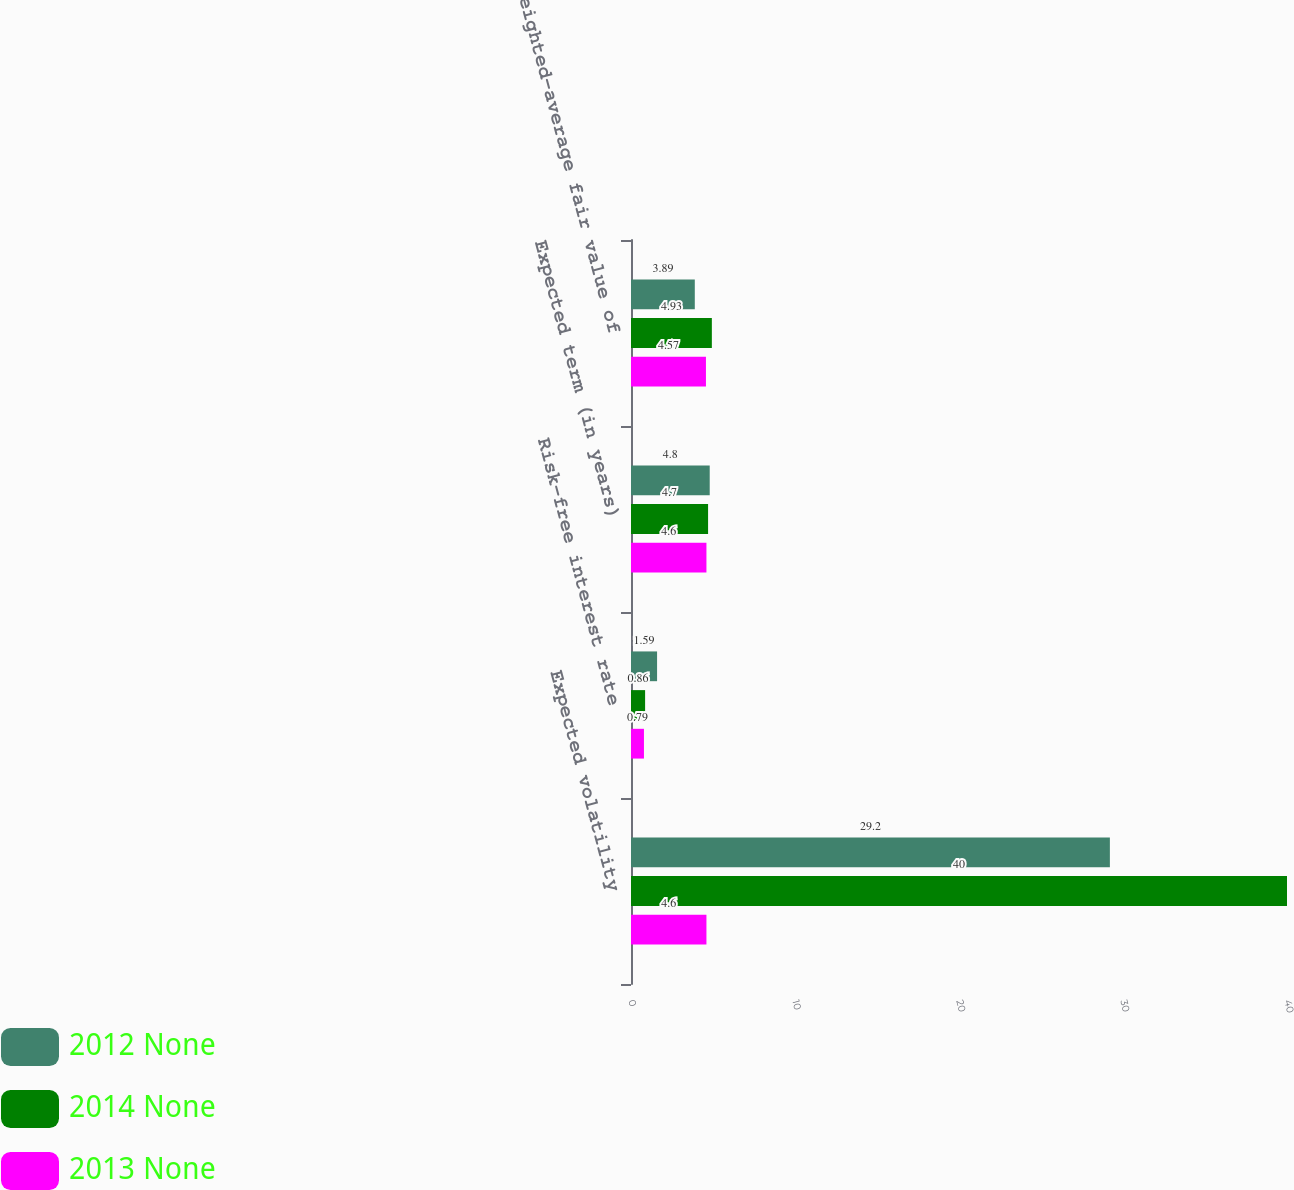Convert chart to OTSL. <chart><loc_0><loc_0><loc_500><loc_500><stacked_bar_chart><ecel><fcel>Expected volatility<fcel>Risk-free interest rate<fcel>Expected term (in years)<fcel>Weighted-average fair value of<nl><fcel>2012 None<fcel>29.2<fcel>1.59<fcel>4.8<fcel>3.89<nl><fcel>2014 None<fcel>40<fcel>0.86<fcel>4.7<fcel>4.93<nl><fcel>2013 None<fcel>4.6<fcel>0.79<fcel>4.6<fcel>4.57<nl></chart> 